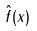<formula> <loc_0><loc_0><loc_500><loc_500>\hat { f } ( x )</formula> 